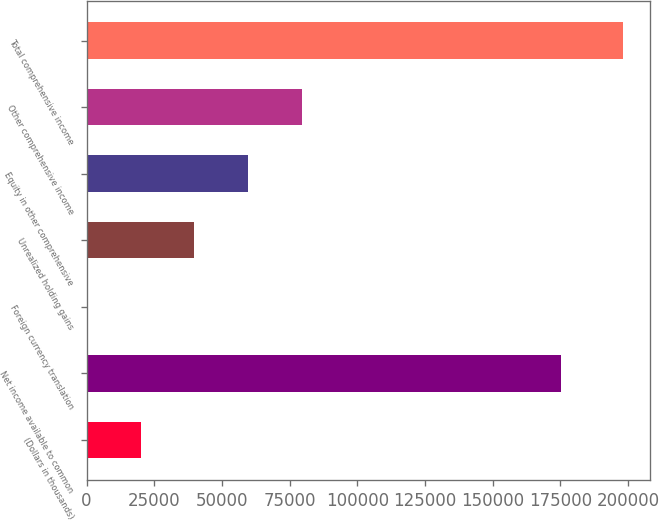Convert chart to OTSL. <chart><loc_0><loc_0><loc_500><loc_500><bar_chart><fcel>(Dollars in thousands)<fcel>Net income available to common<fcel>Foreign currency translation<fcel>Unrealized holding gains<fcel>Equity in other comprehensive<fcel>Other comprehensive income<fcel>Total comprehensive income<nl><fcel>19928.3<fcel>175103<fcel>114<fcel>39742.6<fcel>59556.9<fcel>79371.2<fcel>198257<nl></chart> 